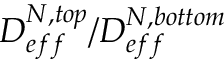<formula> <loc_0><loc_0><loc_500><loc_500>D _ { e f f } ^ { N , t o p } / D _ { e f f } ^ { N , b o t t o m }</formula> 